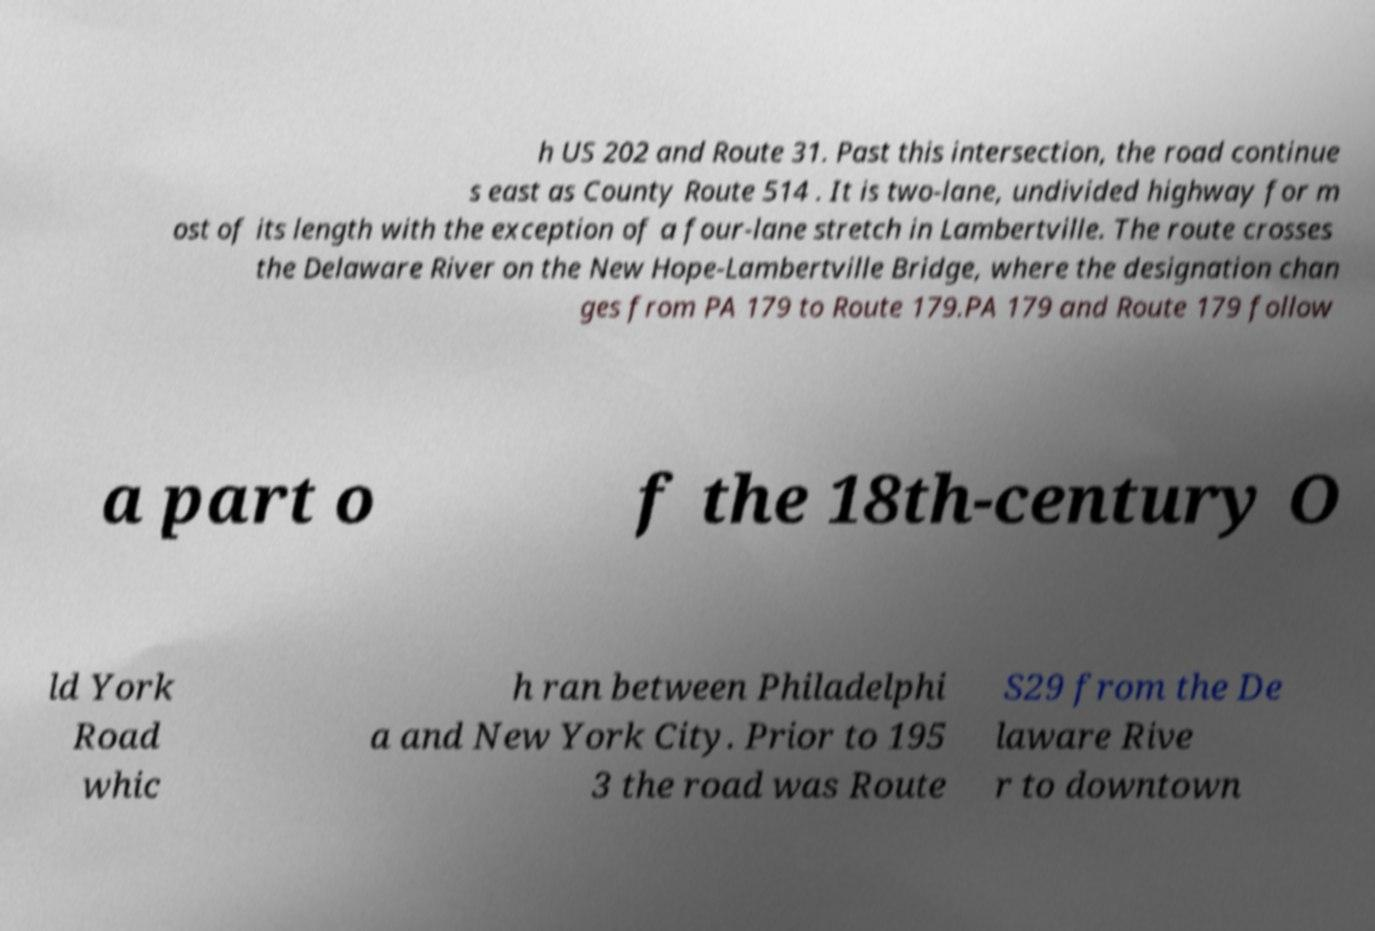Could you extract and type out the text from this image? h US 202 and Route 31. Past this intersection, the road continue s east as County Route 514 . It is two-lane, undivided highway for m ost of its length with the exception of a four-lane stretch in Lambertville. The route crosses the Delaware River on the New Hope-Lambertville Bridge, where the designation chan ges from PA 179 to Route 179.PA 179 and Route 179 follow a part o f the 18th-century O ld York Road whic h ran between Philadelphi a and New York City. Prior to 195 3 the road was Route S29 from the De laware Rive r to downtown 